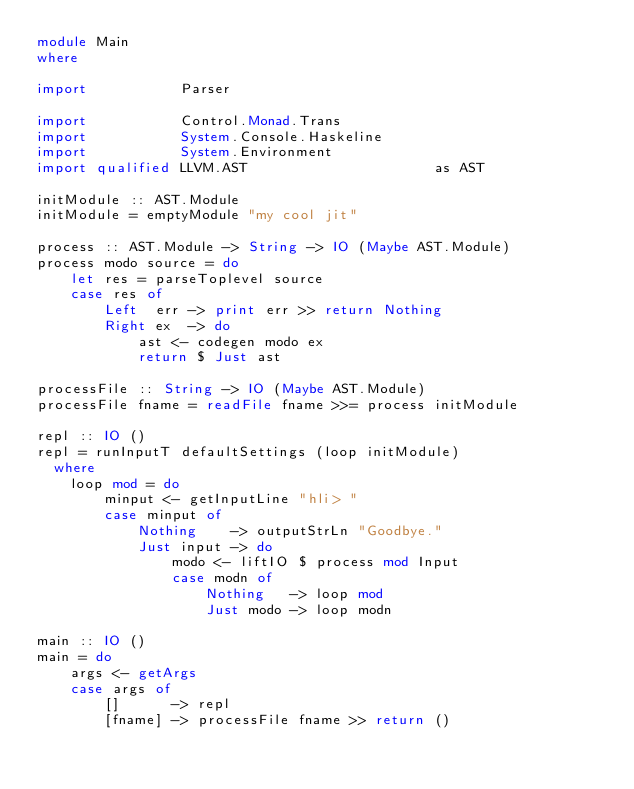<code> <loc_0><loc_0><loc_500><loc_500><_Haskell_>module Main
where

import           Parser

import           Control.Monad.Trans
import           System.Console.Haskeline
import           System.Environment
import qualified LLVM.AST                      as AST

initModule :: AST.Module
initModule = emptyModule "my cool jit"

process :: AST.Module -> String -> IO (Maybe AST.Module)
process modo source = do
    let res = parseToplevel source
    case res of
        Left  err -> print err >> return Nothing
        Right ex  -> do
            ast <- codegen modo ex
            return $ Just ast

processFile :: String -> IO (Maybe AST.Module)
processFile fname = readFile fname >>= process initModule

repl :: IO ()
repl = runInputT defaultSettings (loop initModule)
  where
    loop mod = do
        minput <- getInputLine "hli> "
        case minput of
            Nothing    -> outputStrLn "Goodbye."
            Just input -> do
                modo <- liftIO $ process mod Input
                case modn of
                    Nothing   -> loop mod
                    Just modo -> loop modn

main :: IO ()
main = do
    args <- getArgs
    case args of
        []      -> repl
        [fname] -> processFile fname >> return ()

</code> 